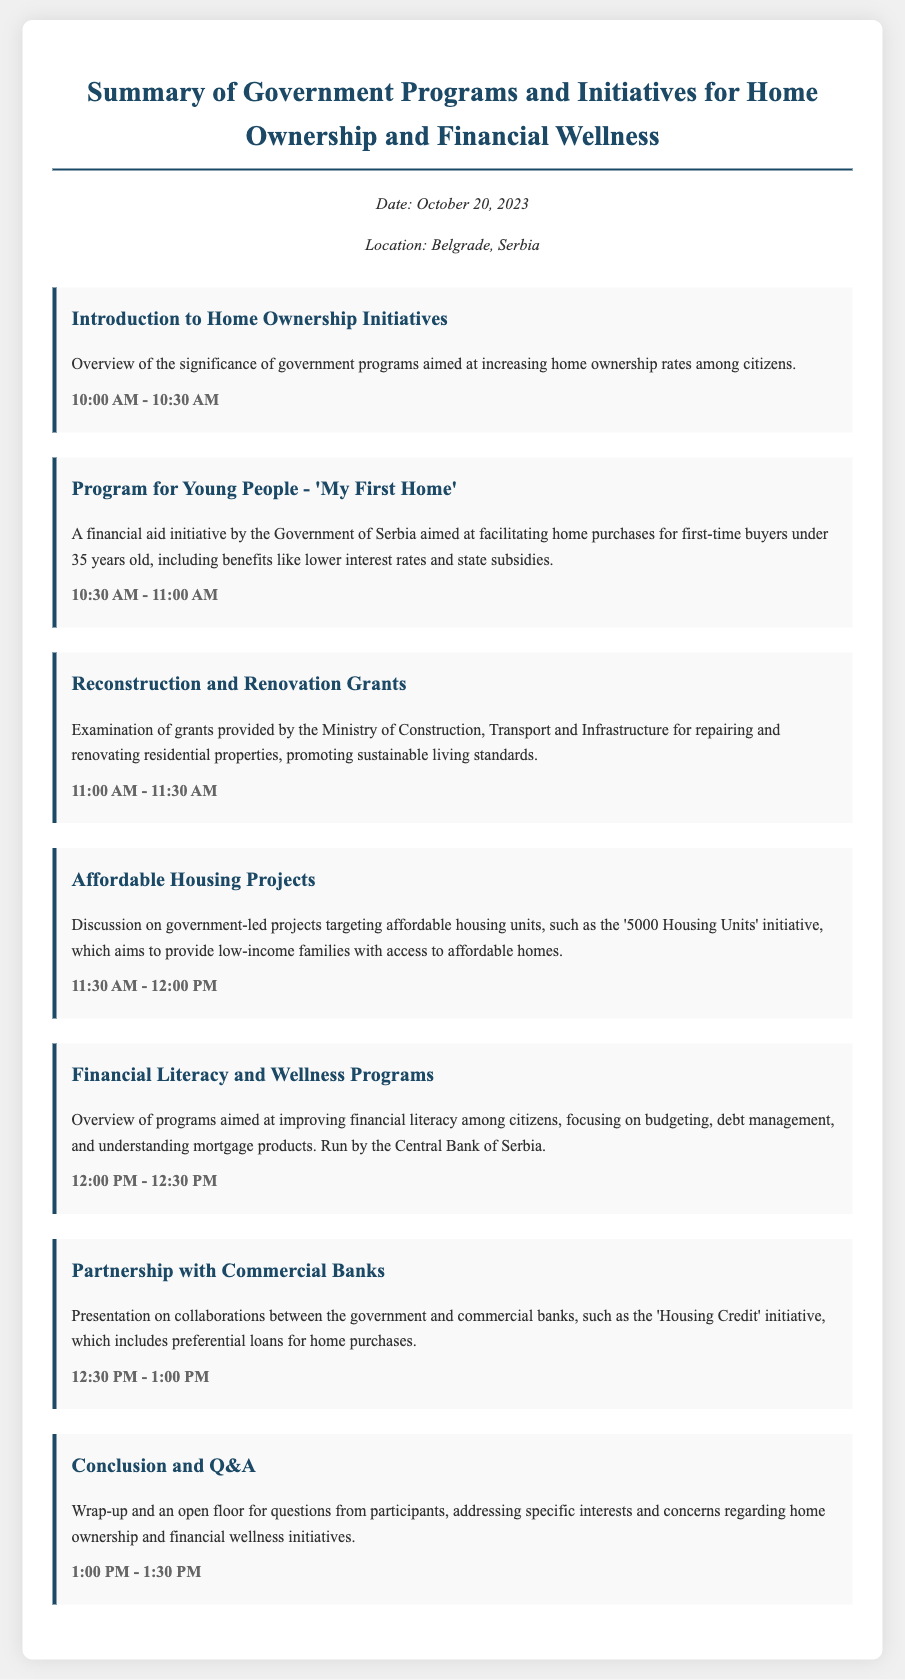What is the date of the agenda? The date of the agenda is provided in the header info section of the document.
Answer: October 20, 2023 What is the location of the event? The location of the event is specified in the header info section of the document.
Answer: Belgrade, Serbia What initiative is aimed at first-time home buyers under 35? This information is mentioned in the agenda item for the program specifically targeting young people.
Answer: 'My First Home' What is the time slot for the Financial Literacy and Wellness Programs? The time slot is clearly stated under the respective agenda item.
Answer: 12:00 PM - 12:30 PM How many housing units are targeted in the '5000 Housing Units' initiative? The exact number is found in the agenda item discussing affordable housing projects.
Answer: 5000 Who runs the Financial Literacy and Wellness Programs? The organization responsible for running these programs is mentioned in the agenda.
Answer: Central Bank of Serbia What type of collaboration is discussed in the agenda? The nature of the collaboration is clearly defined within the relevant agenda item.
Answer: Partnership with Commercial Banks What is the purpose of the Reconstruction and Renovation Grants? The purpose is stated in the description of this agenda item.
Answer: Repairing and renovating residential properties 